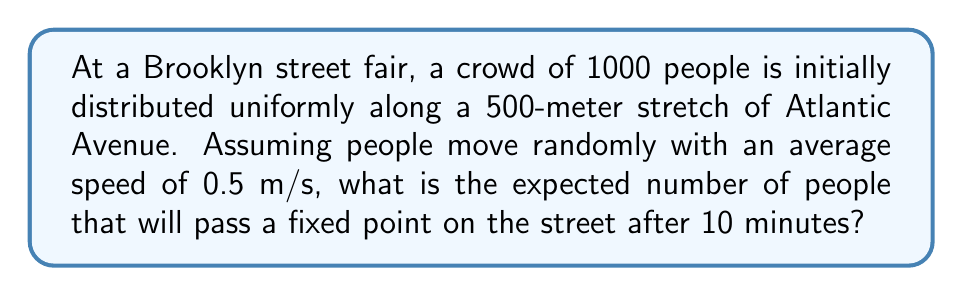Can you solve this math problem? Let's approach this step-by-step:

1) First, we need to calculate the initial density of people:
   $$\text{Density} = \frac{\text{Number of people}}{\text{Length of street}} = \frac{1000 \text{ people}}{500 \text{ m}} = 2 \text{ people/m}$$

2) In a random walk model, the spread of people can be approximated by the diffusion equation. The variance of the distribution after time $t$ is given by:
   $$\sigma^2 = 2Dt$$
   where $D$ is the diffusion coefficient.

3) For random motion in one dimension, $D$ is related to the average speed $v$ by:
   $$D = \frac{v^2}{2}$$

4) With $v = 0.5 \text{ m/s}$, we get:
   $$D = \frac{(0.5 \text{ m/s})^2}{2} = 0.125 \text{ m}^2/\text{s}$$

5) After 10 minutes (600 seconds), the variance is:
   $$\sigma^2 = 2 \cdot 0.125 \text{ m}^2/\text{s} \cdot 600 \text{ s} = 150 \text{ m}^2$$

6) The standard deviation is thus:
   $$\sigma = \sqrt{150 \text{ m}^2} \approx 12.25 \text{ m}$$

7) In a diffusion process, about 68% of the particles (people in this case) will be within one standard deviation of the starting point after time $t$.

8) So, the number of people expected to pass a fixed point is approximately:
   $$N = 0.68 \cdot \text{Density} \cdot 2\sigma = 0.68 \cdot 2 \text{ people/m} \cdot 2 \cdot 12.25 \text{ m} \approx 33.32 \text{ people}$$
Answer: 33 people 